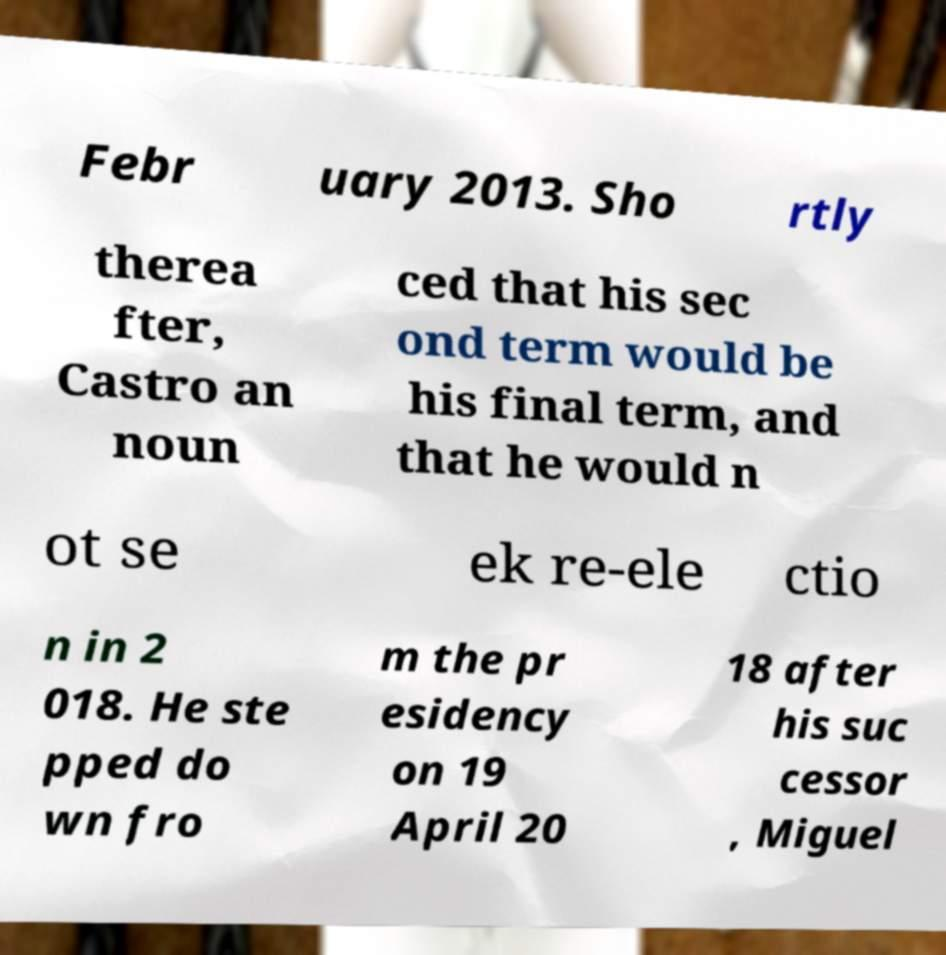What messages or text are displayed in this image? I need them in a readable, typed format. Febr uary 2013. Sho rtly therea fter, Castro an noun ced that his sec ond term would be his final term, and that he would n ot se ek re-ele ctio n in 2 018. He ste pped do wn fro m the pr esidency on 19 April 20 18 after his suc cessor , Miguel 